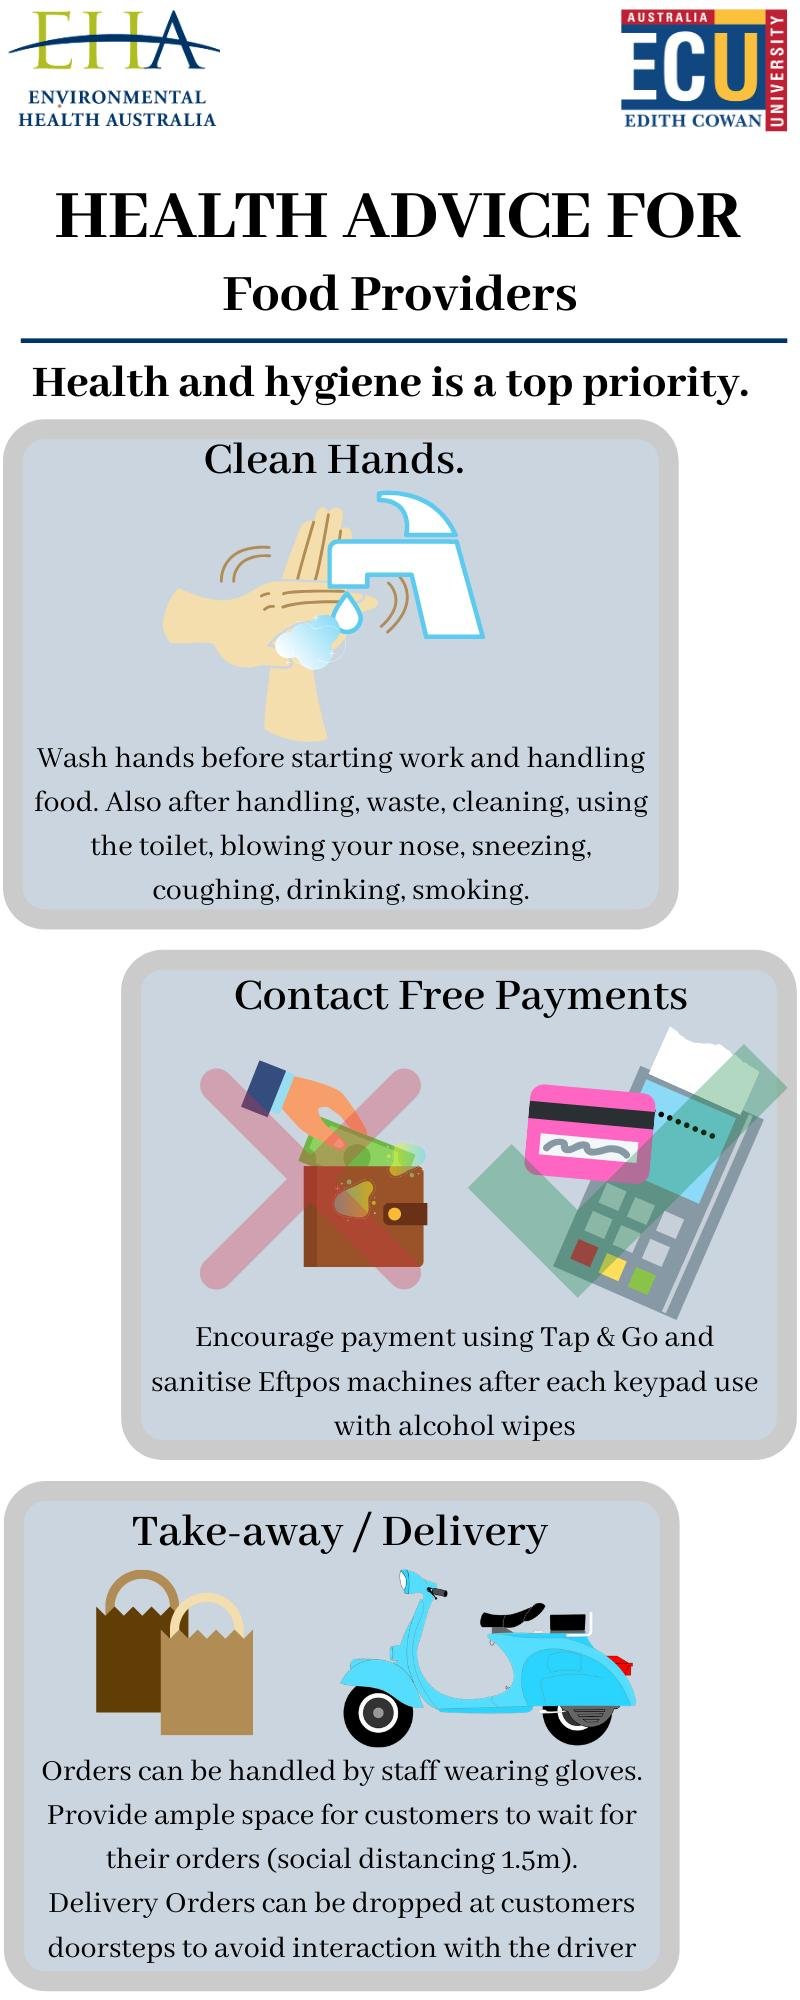Specify some key components in this picture. The third major health advice and hygiene priority for food providers in the take-away and delivery industry is to prioritize maintaining high standards of personal and food hygiene to ensure the safety and quality of their products. The second major health advice and hygiene priority for food providers is to ensure proper contact and payment hygiene. The first major health advice and hygiene priority for food providers is to maintain clean hands. 